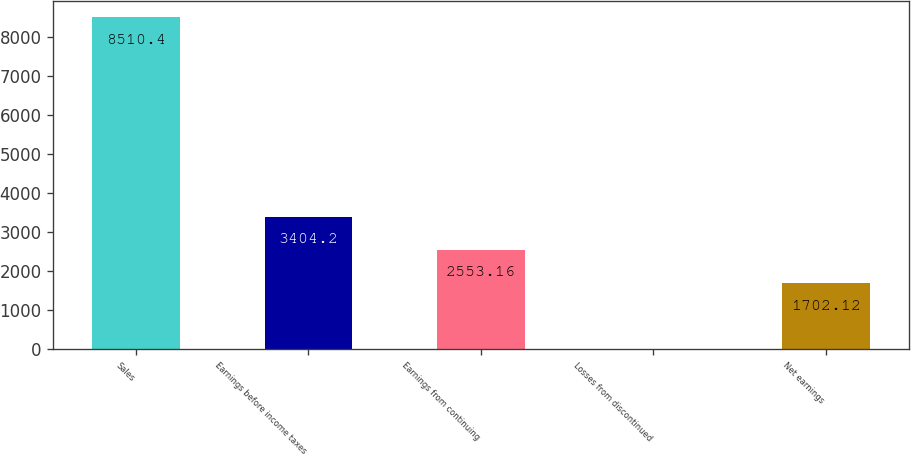<chart> <loc_0><loc_0><loc_500><loc_500><bar_chart><fcel>Sales<fcel>Earnings before income taxes<fcel>Earnings from continuing<fcel>Losses from discontinued<fcel>Net earnings<nl><fcel>8510.4<fcel>3404.2<fcel>2553.16<fcel>0.04<fcel>1702.12<nl></chart> 